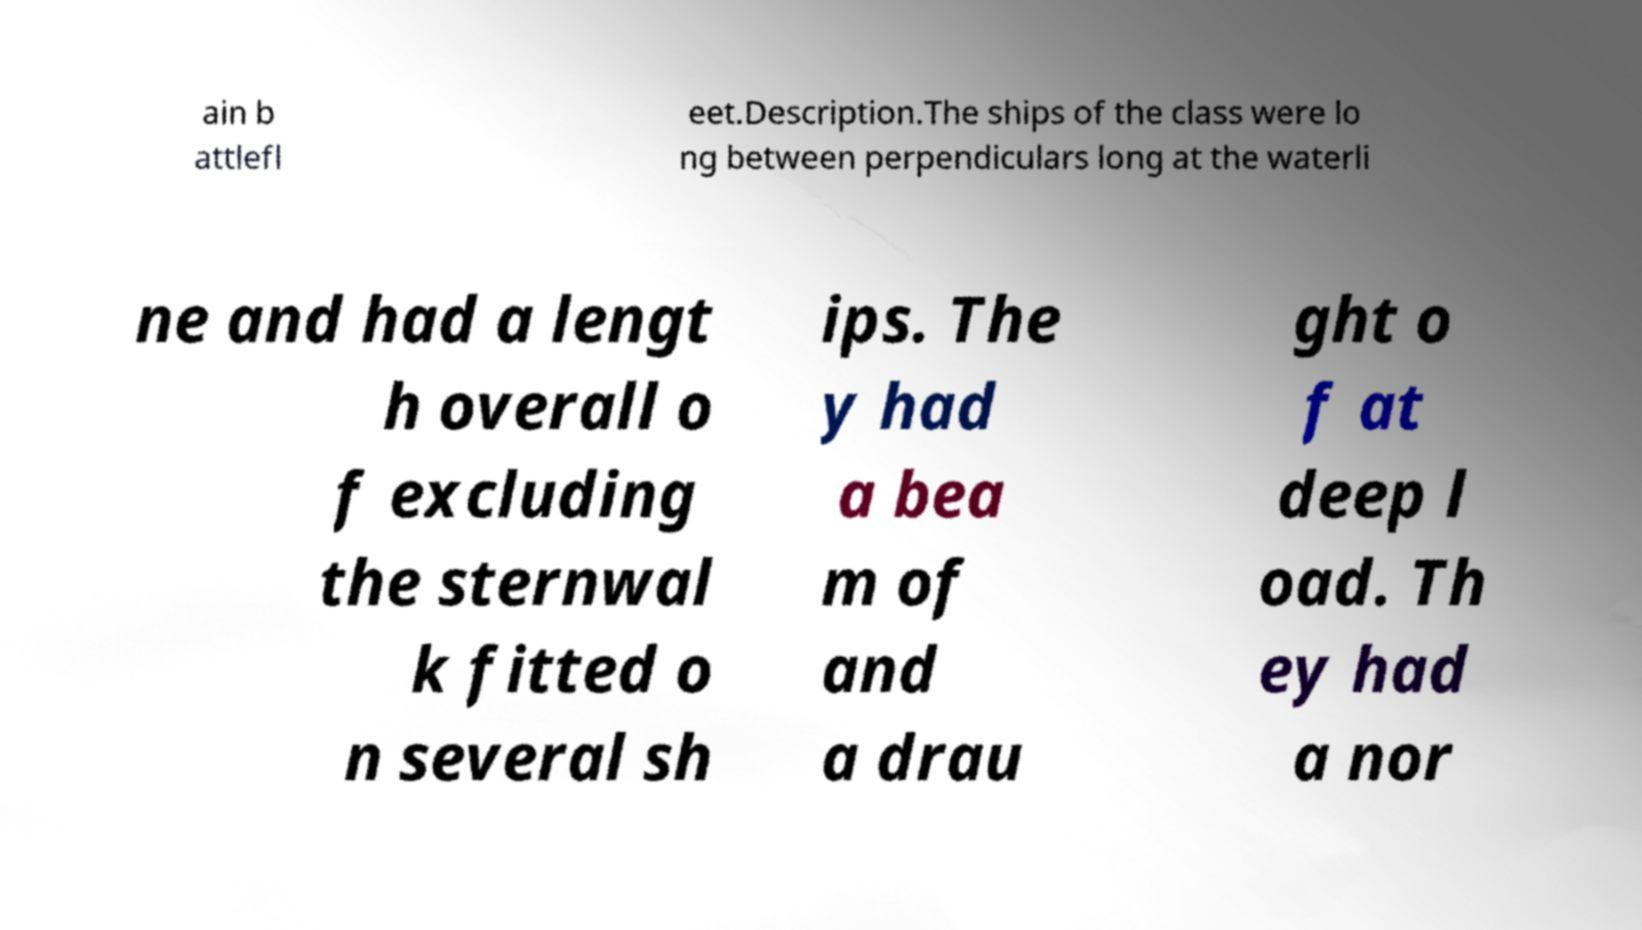Please identify and transcribe the text found in this image. ain b attlefl eet.Description.The ships of the class were lo ng between perpendiculars long at the waterli ne and had a lengt h overall o f excluding the sternwal k fitted o n several sh ips. The y had a bea m of and a drau ght o f at deep l oad. Th ey had a nor 